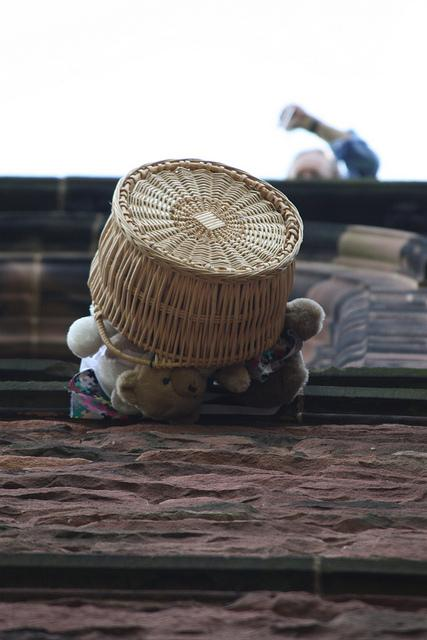What is the wicker basket covering on top of? teddy bears 